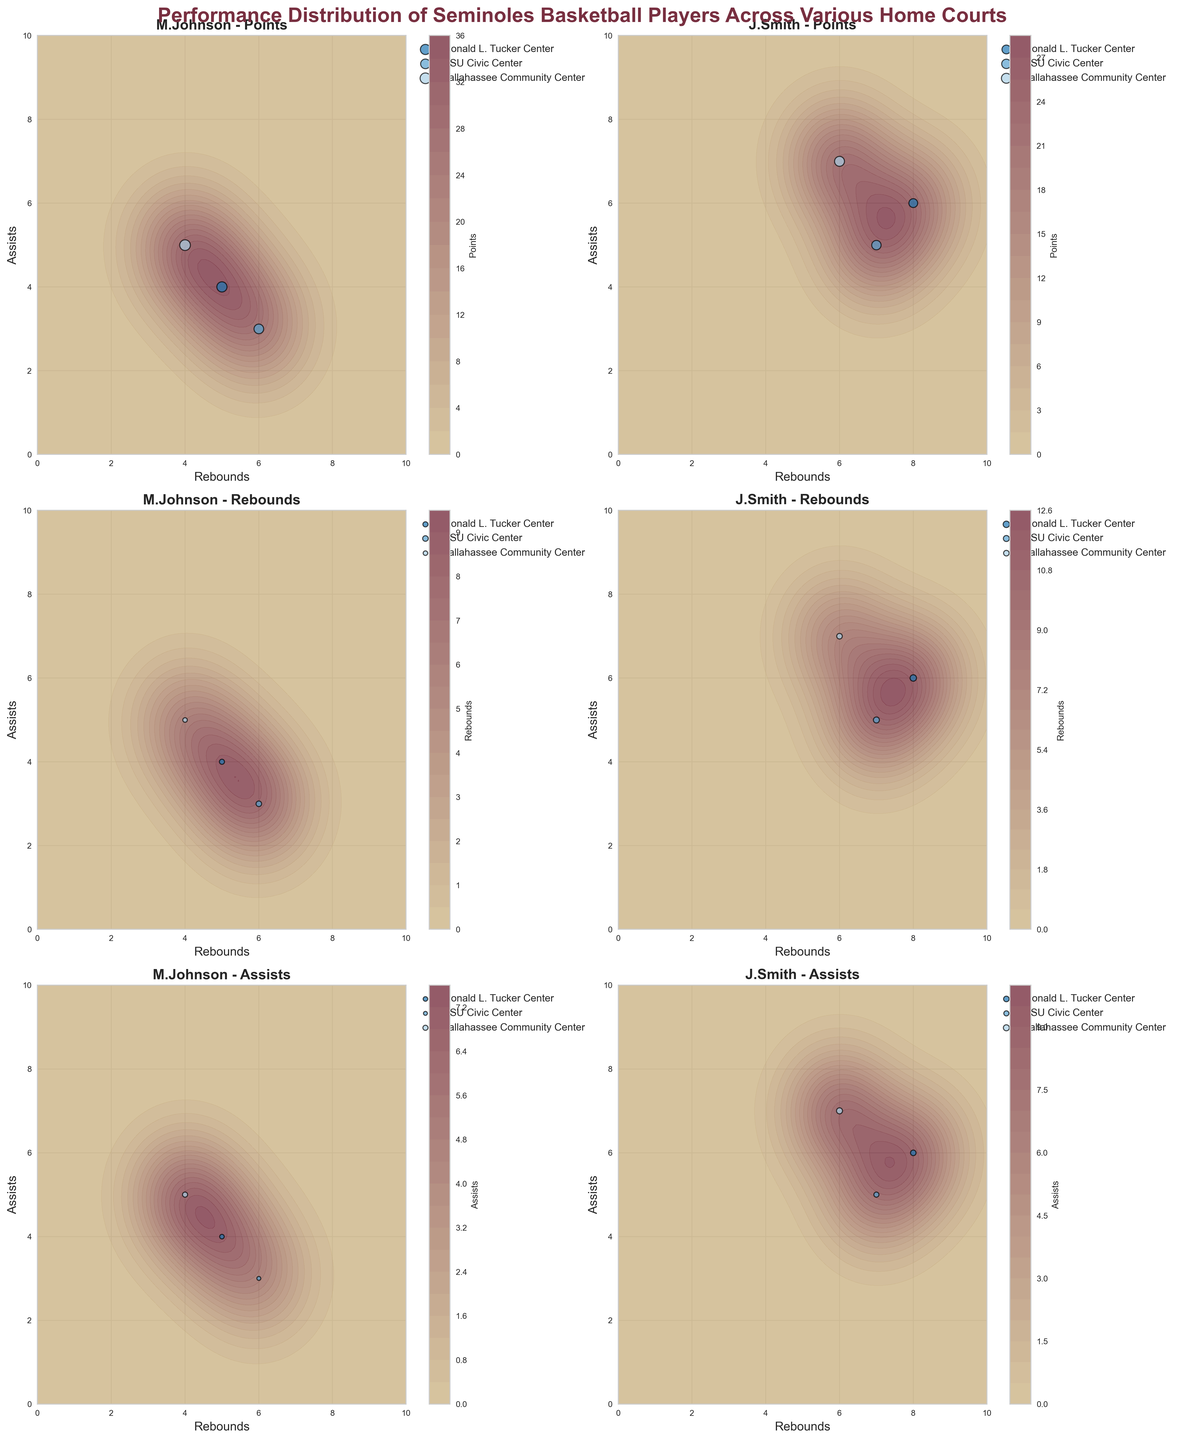What is the title of the figure? The title is displayed at the top of the figure and reads "Performance Distribution of Seminoles Basketball Players Across Various Home Courts"
Answer: Performance Distribution of Seminoles Basketball Players Across Various Home Courts How many subplots are in the figure? The figure contains a grid of subplots arranged in three rows and two columns, resulting in a total of six subplots.
Answer: Six Which home court does M. Johnson perform better in terms of points? Looking at the contour plots for M. Johnson's points, observe the scatter points with larger sizes representing the points scored at different home courts.
Answer: Tallahassee Community Center Which metric is indicated by the colorbars on each subplot? Each subplot has a colorbar indicating the intensity of the contour plot. The title of each subplot specifies the metric being visualized.
Answer: The metrics are Points, Rebounds, and Assists depending on the subplot How do D. Williams' points compare between Donald L. Tucker Center and FSU Civic Center? To determine this, locate the subplots related to D. Williams and visually compare the scatter points for points at the respective home courts. The size and color of scatter points indicate performance.
Answer: Higher at FSU Civic Center What is the general trend of rebounds and assists for J. Smith? Observe the subplots for J. Smith that depict rebounds and assists. The contour plots and scatter points give information about the distribution and value of rebounds and assists across different home courts.
Answer: Fairly balanced across all courts Between which combination of rebounds and assists does S. Miller score the highest points? Examine the subplot for S. Miller's points. The highest points are indicated by the darkest color in the contour plot, and look for corresponding rebounds and assists values at those points.
Answer: Around 14 rebounds and 9 assists Which player has the most balanced distribution of assists across all home courts? By looking at each player's subplot for assists, detect which player's contour plot shows a more uniform spread of colors, indicating balanced distribution.
Answer: J. Smith Does K. Brown have a higher points score at Donald L. Tucker Center or Tallahassee Community Center? Compare the scatter points in K. Brown's point subplot across the mentioned home courts. Notice the relative size and color density.
Answer: Donald L. Tucker Center 